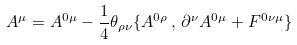<formula> <loc_0><loc_0><loc_500><loc_500>A ^ { \mu } = A ^ { 0 \mu } - \frac { 1 } { 4 } \theta _ { \rho \nu } \{ A ^ { 0 \rho } \, , \, \partial ^ { \nu } A ^ { 0 \mu } + F ^ { 0 \nu \mu } \}</formula> 